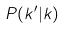<formula> <loc_0><loc_0><loc_500><loc_500>P ( k ^ { \prime } | k )</formula> 